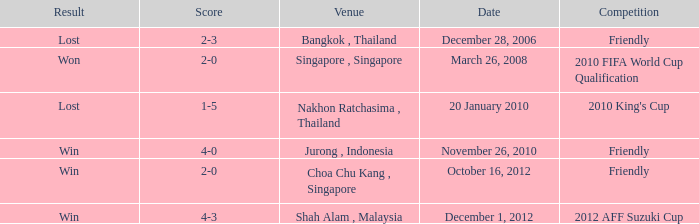Name the venue for friendly competition october 16, 2012 Choa Chu Kang , Singapore. 